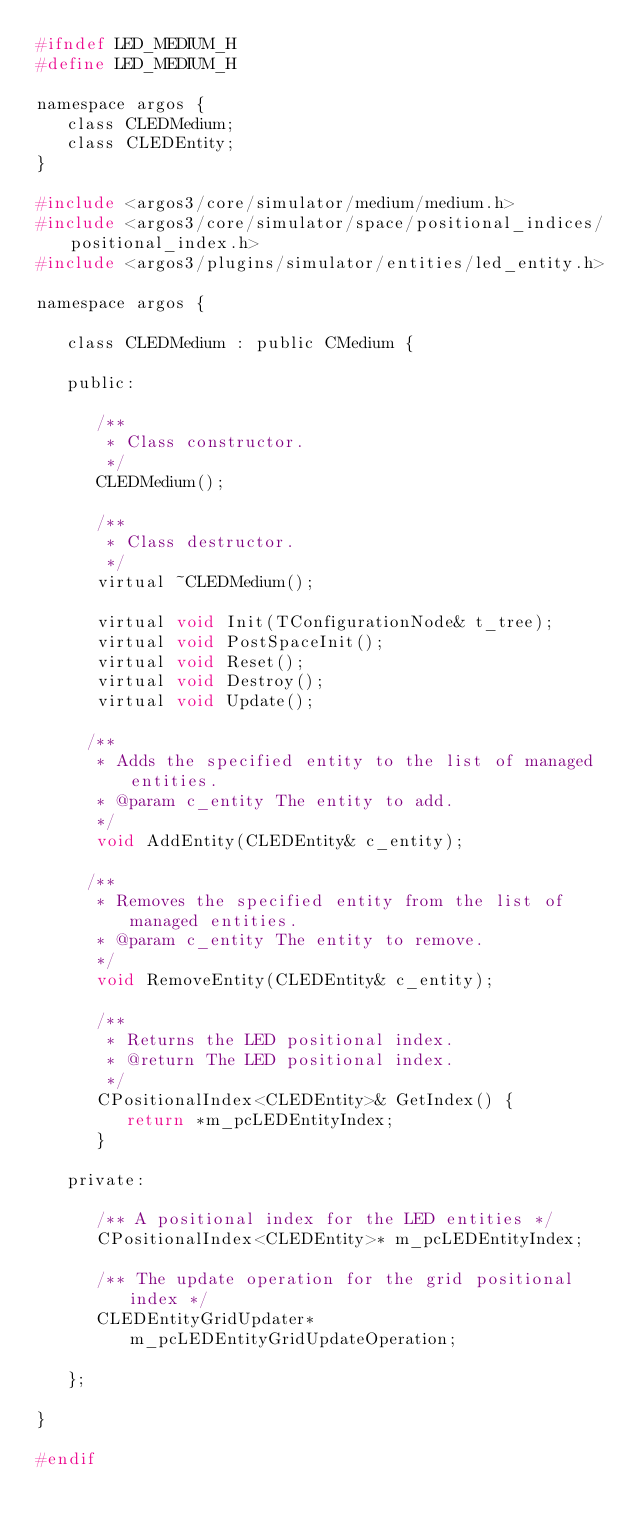Convert code to text. <code><loc_0><loc_0><loc_500><loc_500><_C_>#ifndef LED_MEDIUM_H
#define LED_MEDIUM_H

namespace argos {
   class CLEDMedium;
   class CLEDEntity;
}

#include <argos3/core/simulator/medium/medium.h>
#include <argos3/core/simulator/space/positional_indices/positional_index.h>
#include <argos3/plugins/simulator/entities/led_entity.h>

namespace argos {

   class CLEDMedium : public CMedium {

   public:

      /**
       * Class constructor.
       */
      CLEDMedium();

      /**
       * Class destructor.
       */
      virtual ~CLEDMedium();

      virtual void Init(TConfigurationNode& t_tree);
      virtual void PostSpaceInit();
      virtual void Reset();
      virtual void Destroy();
      virtual void Update();

     /**
      * Adds the specified entity to the list of managed entities.
      * @param c_entity The entity to add.
      */
      void AddEntity(CLEDEntity& c_entity);

     /**
      * Removes the specified entity from the list of managed entities.
      * @param c_entity The entity to remove.
      */
      void RemoveEntity(CLEDEntity& c_entity);

      /**
       * Returns the LED positional index.
       * @return The LED positional index.
       */
      CPositionalIndex<CLEDEntity>& GetIndex() {
         return *m_pcLEDEntityIndex;
      }

   private:

      /** A positional index for the LED entities */
      CPositionalIndex<CLEDEntity>* m_pcLEDEntityIndex;

      /** The update operation for the grid positional index */
      CLEDEntityGridUpdater* m_pcLEDEntityGridUpdateOperation;

   };

}

#endif
</code> 